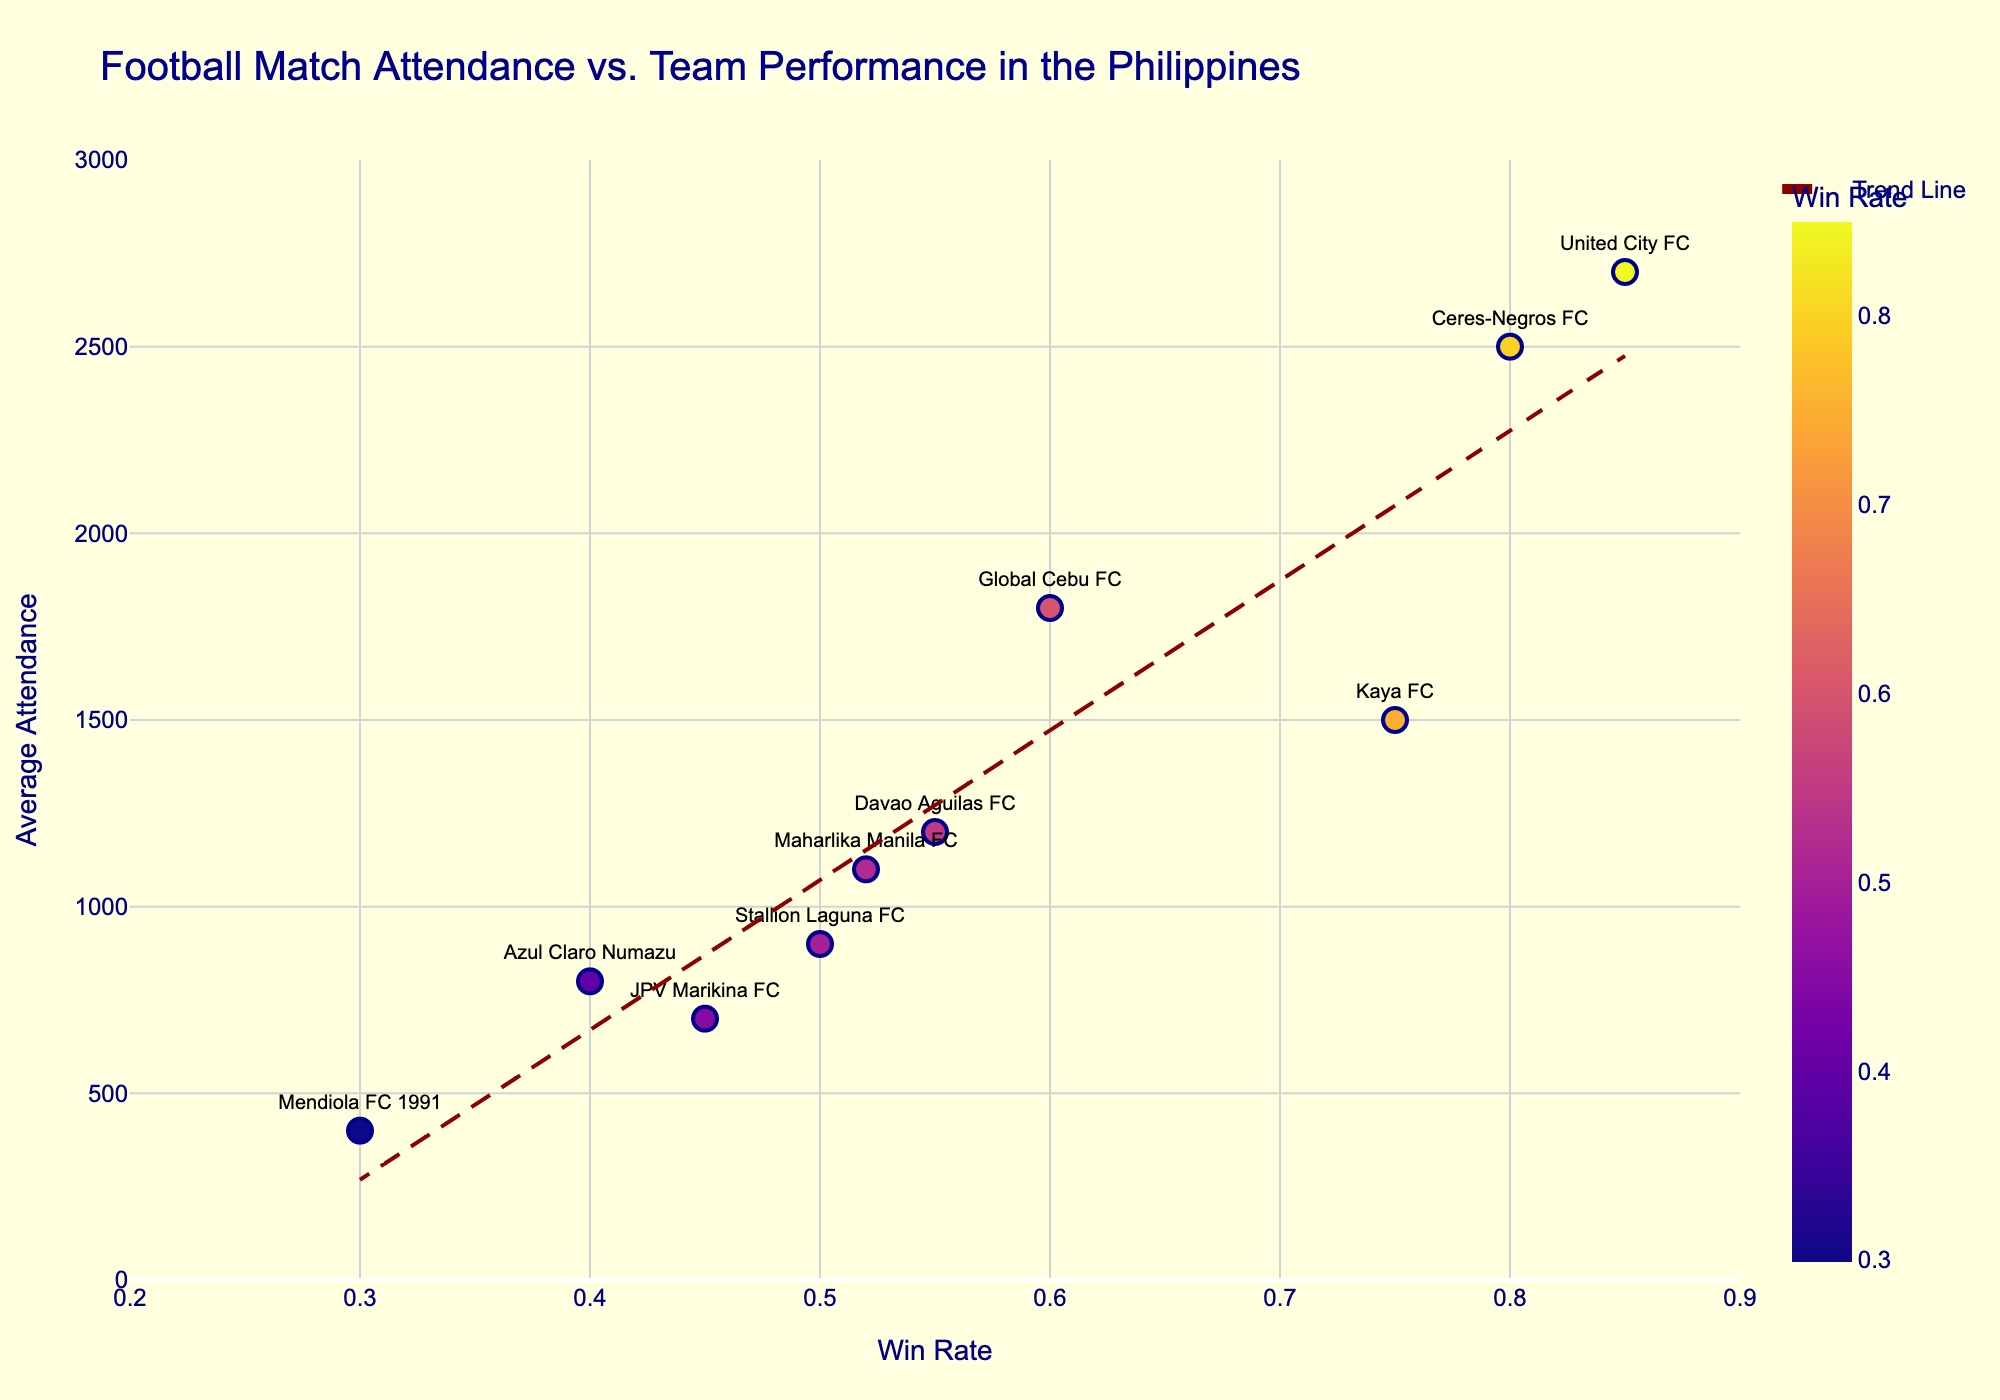What is the title of the scatter plot? The title is displayed at the top of the plot and provides a brief overview of the data visualized.
Answer: Football Match Attendance vs. Team Performance in the Philippines Which team has the highest attendance? By looking at the vertical position of the data points, the team with the highest value on the y-axis represents the highest attendance.
Answer: United City FC How many teams have an average attendance of over 2000? Identify the data points where the y-values (attendance) are greater than 2000. There are two such data points.
Answer: 2 Which team has the lowest win rate, and what's their attendance? Identify the data point with the lowest x-value (win rate) and then read its y-value (attendance).
Answer: Mendiola FC 1991, 400 Does the trend line indicate a positive or negative correlation between win rate and attendance? By observing the slope of the trend line, if it goes upwards from left to right, it indicates a positive correlation.
Answer: Positive Which team with a win rate above 0.50 has the lowest attendance? First, filter the data points where the x-value (win rate) is above 0.50, then find the one with the lowest y-value (attendance).
Answer: Maharlika Manila FC What is the approximate average attendance for teams with a win rate of 0.70 or higher? Identify the data points with a win rate of 0.70 or higher, sum their attendance values, and divide by the number of these data points. (Attendance = 1500+2500+2700).
Answer: 2233 Compare the attendance of Kaya FC and JPV Marikina FC. Which has higher attendance and by how much? Check the y-values for both teams and subtract the smaller value from the larger one. Kaya FC has 1500 and JPV Marikina FC has 700.
Answer: Kaya FC, 800 What does the size of the markers represent in this plot? By reading the plot's details, the size of the markers corresponds to the attendance of each team.
Answer: Attendance Is there any team with both low attendance and low win rate? Identify data points that are towards the lower end of both x (win rate) and y (attendance) axes.
Answer: Mendiola FC 1991 